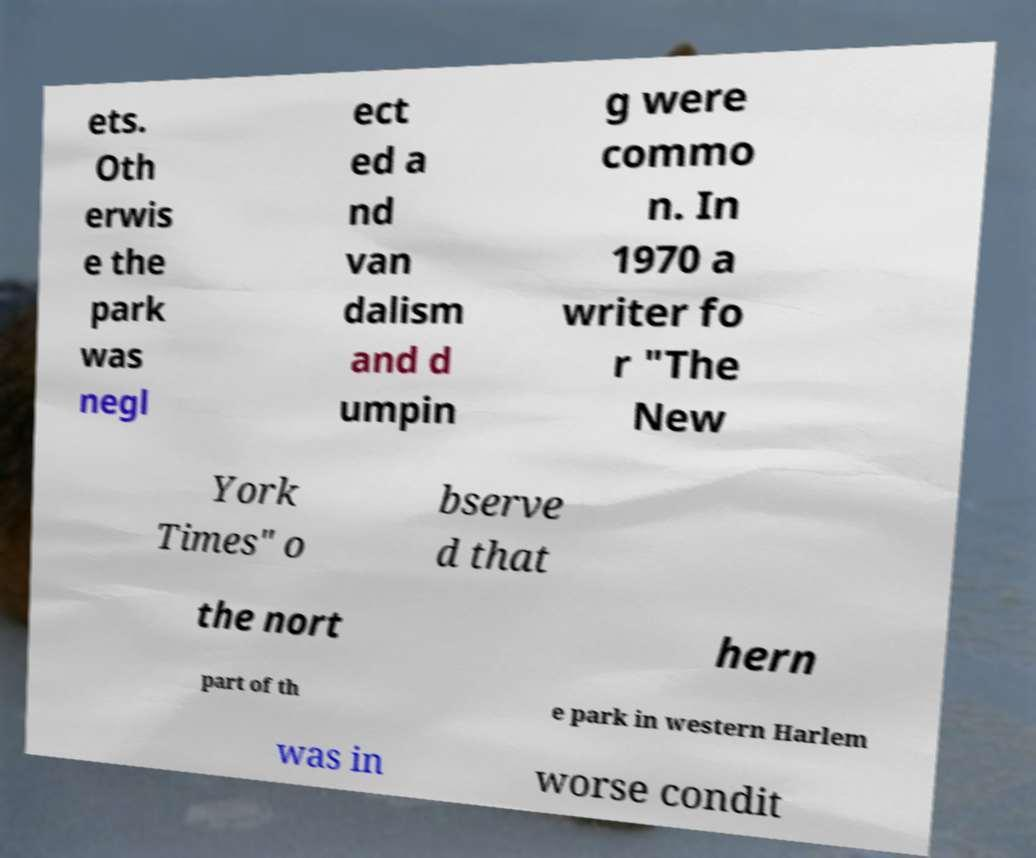I need the written content from this picture converted into text. Can you do that? ets. Oth erwis e the park was negl ect ed a nd van dalism and d umpin g were commo n. In 1970 a writer fo r "The New York Times" o bserve d that the nort hern part of th e park in western Harlem was in worse condit 